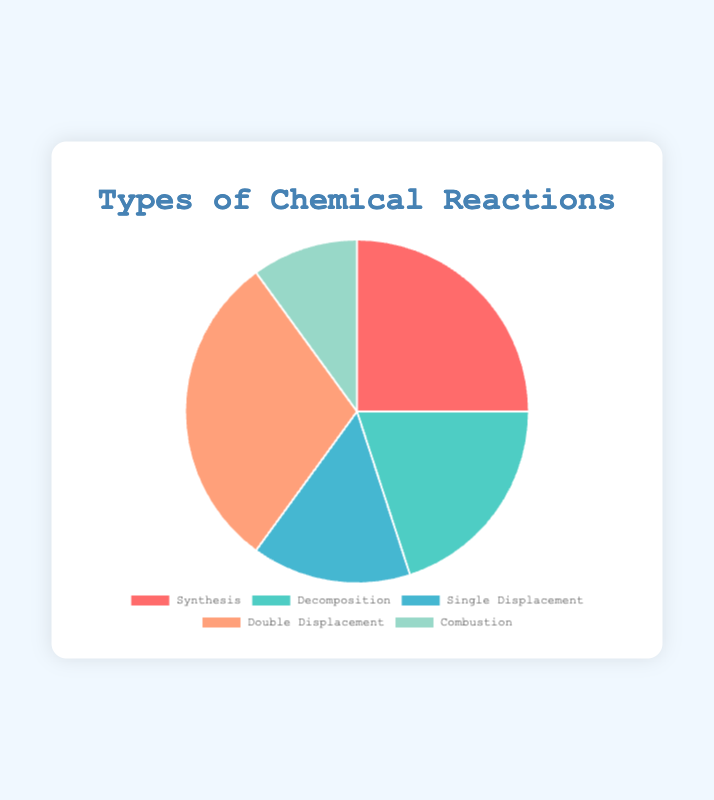What's the most frequently studied type of chemical reaction? The pie chart shows the proportions of different types of chemical reactions studied. The largest segment, representing 30%, is for Double Displacement reactions.
Answer: Double Displacement Which type of chemical reaction is studied less than Single Displacement? The pie chart shows that Single Displacement accounts for 15%. The only reaction with a smaller percentage is Combustion, at 10%.
Answer: Combustion What's the combined percentage of Synthesis and Decomposition reactions? According to the pie chart, Synthesis makes up 25% and Decomposition makes up 20%. Adding these together gives 25% + 20% = 45%.
Answer: 45% What is the visual attribute of the segment representing the least studied chemical reaction? The Combustion reaction is the least studied at 10%, and its segment in the pie chart is represented in a green color.
Answer: Green Which two types of chemical reactions together make up half of the total reactions studied? According to the pie chart, Double Displacement is 30% and Decomposition is 20%. Together, they add up to 30% + 20% = 50%.
Answer: Double Displacement and Decomposition Is the percentage of Double Displacement reactions greater than the sum of Combustion and Single Displacement reactions? Double Displacement reactions make up 30%, while the sum of Combustion (10%) and Single Displacement (15%) is 10% + 15% = 25%. Since 30% is greater than 25%, the answer is yes.
Answer: Yes What is the total percentage of reactions studied if we exclude Synthesis and Single Displacement? Excluding Synthesis (25%) and Single Displacement (15%), we add the percentages of Decomposition (20%), Double Displacement (30%), and Combustion (10%): 20% + 30% + 10% = 60%.
Answer: 60% By how much does the percentage of Synthesis reactions exceed that of Combustion reactions? Synthesis reactions are 25%, and Combustion reactions are 10%. The difference is 25% - 10% = 15%.
Answer: 15% 